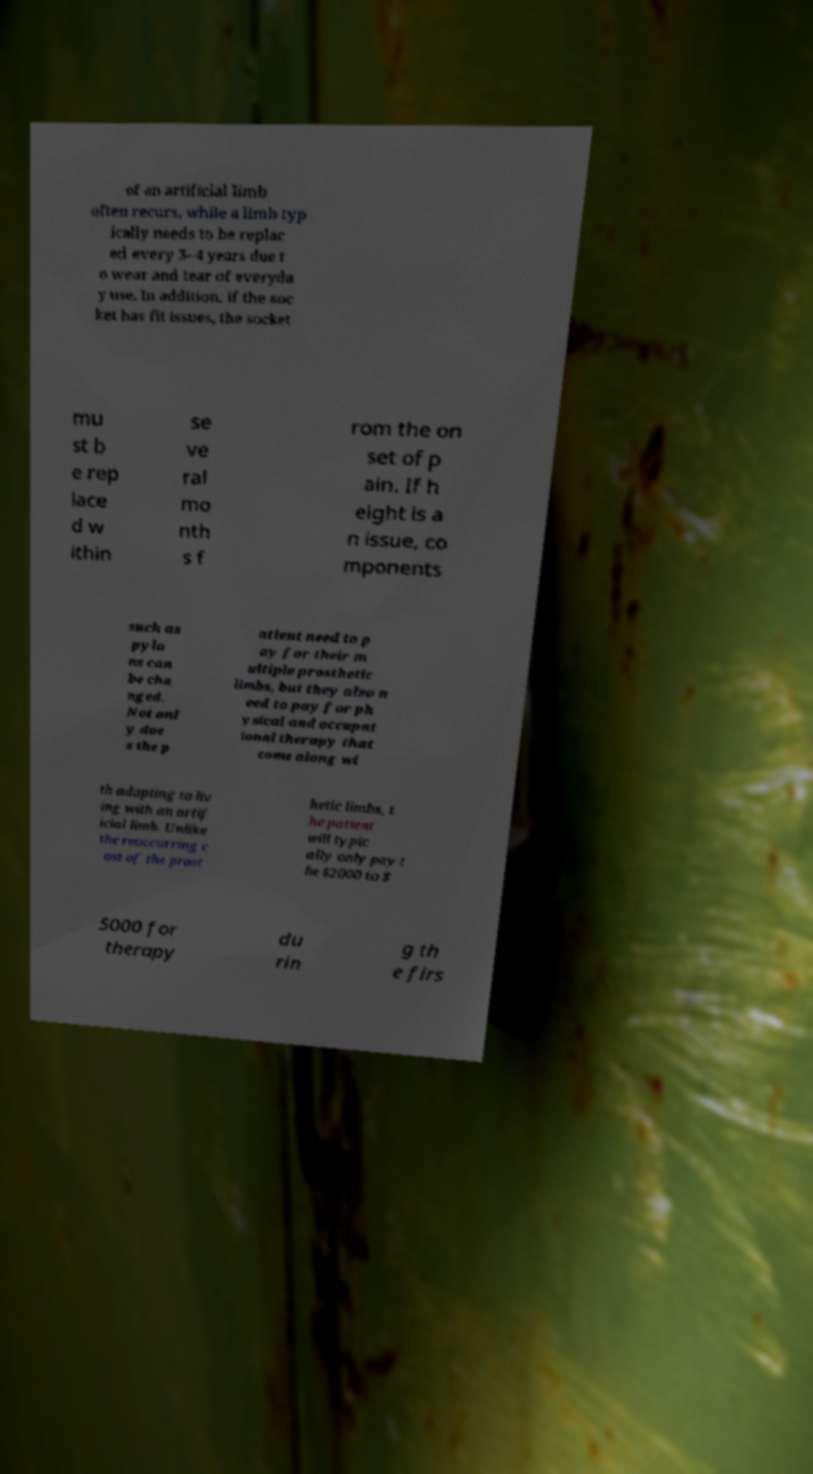Can you accurately transcribe the text from the provided image for me? of an artificial limb often recurs, while a limb typ ically needs to be replac ed every 3–4 years due t o wear and tear of everyda y use. In addition, if the soc ket has fit issues, the socket mu st b e rep lace d w ithin se ve ral mo nth s f rom the on set of p ain. If h eight is a n issue, co mponents such as pylo ns can be cha nged. Not onl y doe s the p atient need to p ay for their m ultiple prosthetic limbs, but they also n eed to pay for ph ysical and occupat ional therapy that come along wi th adapting to liv ing with an artif icial limb. Unlike the reoccurring c ost of the prost hetic limbs, t he patient will typic ally only pay t he $2000 to $ 5000 for therapy du rin g th e firs 